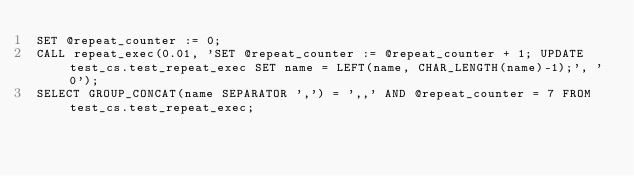Convert code to text. <code><loc_0><loc_0><loc_500><loc_500><_SQL_>SET @repeat_counter := 0;
CALL repeat_exec(0.01, 'SET @repeat_counter := @repeat_counter + 1; UPDATE test_cs.test_repeat_exec SET name = LEFT(name, CHAR_LENGTH(name)-1);', '0');
SELECT GROUP_CONCAT(name SEPARATOR ',') = ',,' AND @repeat_counter = 7 FROM test_cs.test_repeat_exec;

</code> 